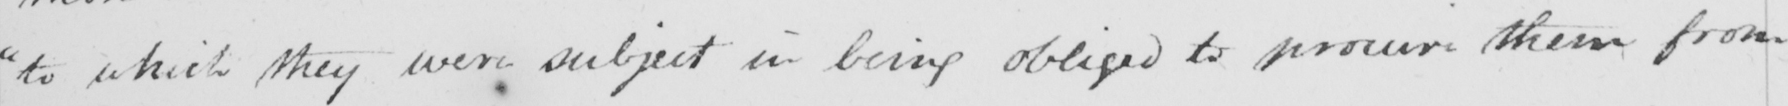Can you read and transcribe this handwriting? " to which they were subject in being obliged to procure them from 